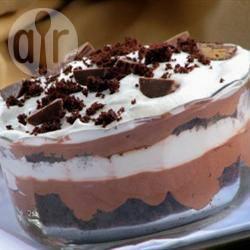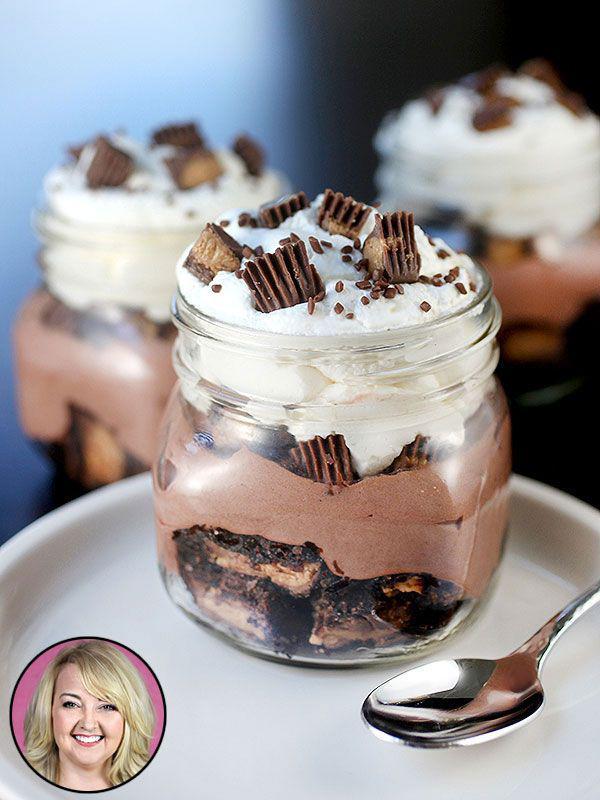The first image is the image on the left, the second image is the image on the right. For the images displayed, is the sentence "One image shows a dessert with no reddish-purple layer served in one footed glass, and the other shows a non-footed glass containing a reddish-purple layer." factually correct? Answer yes or no. No. The first image is the image on the left, the second image is the image on the right. For the images displayed, is the sentence "In one image, a large layered dessert with chocolate garnish is made in a clear glass footed bowl, while a second image shows one or more individual desserts made with red berries." factually correct? Answer yes or no. No. 